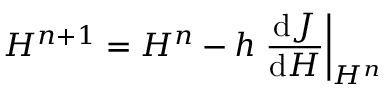<formula> <loc_0><loc_0><loc_500><loc_500>H ^ { n + 1 } = H ^ { n } - h \frac { d J } { d H } \right | _ { H ^ { n } }</formula> 